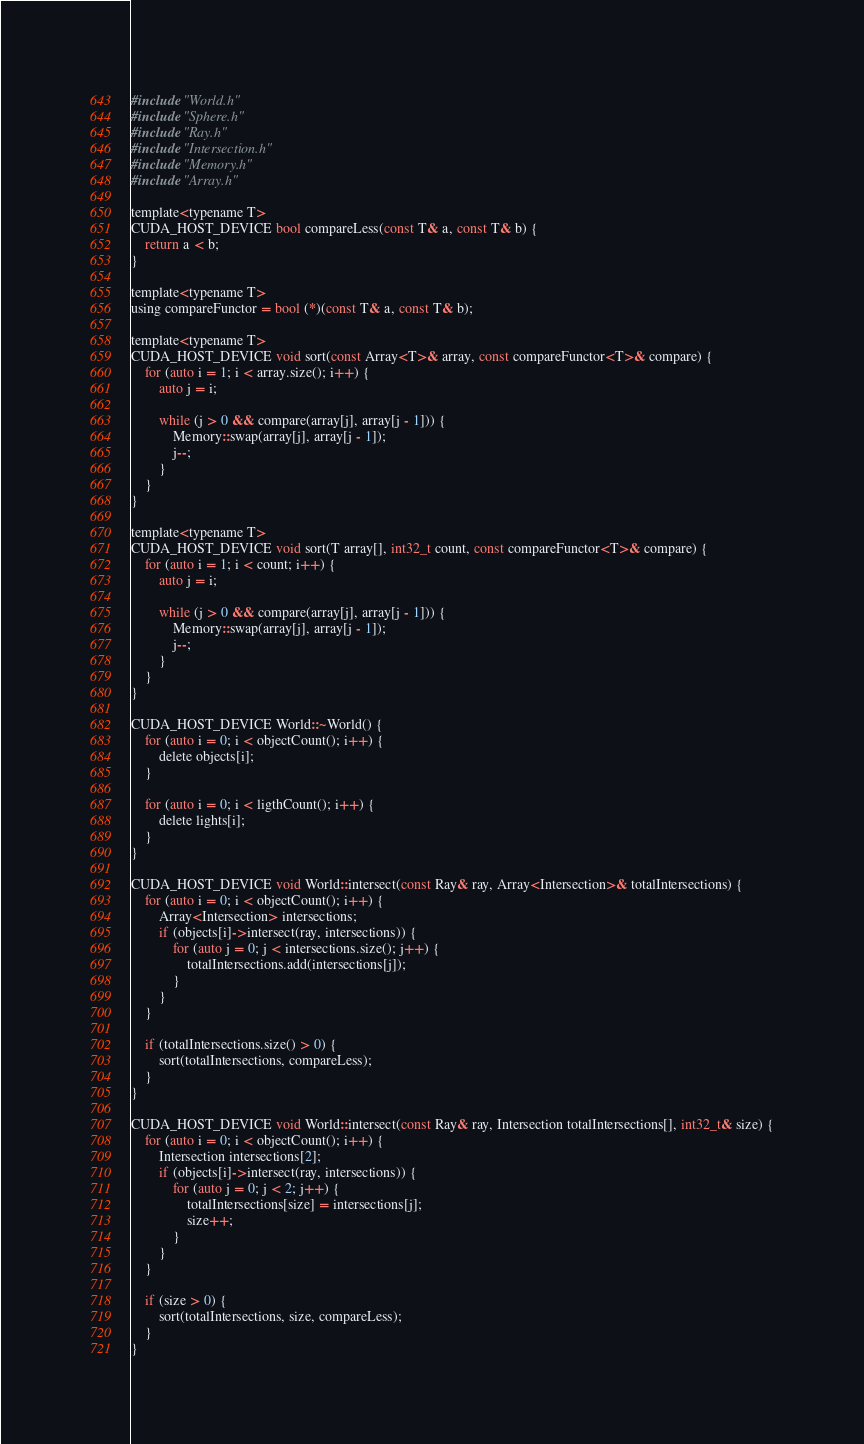Convert code to text. <code><loc_0><loc_0><loc_500><loc_500><_Cuda_>#include "World.h"
#include "Sphere.h"
#include "Ray.h"
#include "Intersection.h"
#include "Memory.h"
#include "Array.h"

template<typename T>
CUDA_HOST_DEVICE bool compareLess(const T& a, const T& b) {
    return a < b;
}

template<typename T>
using compareFunctor = bool (*)(const T& a, const T& b);

template<typename T>
CUDA_HOST_DEVICE void sort(const Array<T>& array, const compareFunctor<T>& compare) {
    for (auto i = 1; i < array.size(); i++) {
        auto j = i;

        while (j > 0 && compare(array[j], array[j - 1])) {
            Memory::swap(array[j], array[j - 1]);
            j--;
        }
    }
}

template<typename T>
CUDA_HOST_DEVICE void sort(T array[], int32_t count, const compareFunctor<T>& compare) {
    for (auto i = 1; i < count; i++) {
        auto j = i;

        while (j > 0 && compare(array[j], array[j - 1])) {
            Memory::swap(array[j], array[j - 1]);
            j--;
        }
    }
}

CUDA_HOST_DEVICE World::~World() {
    for (auto i = 0; i < objectCount(); i++) {
        delete objects[i];
    }

    for (auto i = 0; i < ligthCount(); i++) {
        delete lights[i];
    }
}

CUDA_HOST_DEVICE void World::intersect(const Ray& ray, Array<Intersection>& totalIntersections) {
    for (auto i = 0; i < objectCount(); i++) {
        Array<Intersection> intersections;
        if (objects[i]->intersect(ray, intersections)) {
            for (auto j = 0; j < intersections.size(); j++) {
                totalIntersections.add(intersections[j]);
            }
        }
    }

    if (totalIntersections.size() > 0) {
        sort(totalIntersections, compareLess);
    }
}

CUDA_HOST_DEVICE void World::intersect(const Ray& ray, Intersection totalIntersections[], int32_t& size) {
    for (auto i = 0; i < objectCount(); i++) {
        Intersection intersections[2];
        if (objects[i]->intersect(ray, intersections)) {
            for (auto j = 0; j < 2; j++) {
                totalIntersections[size] = intersections[j];
                size++;
            }
        }
    }

    if (size > 0) {
        sort(totalIntersections, size, compareLess);
    }
}</code> 